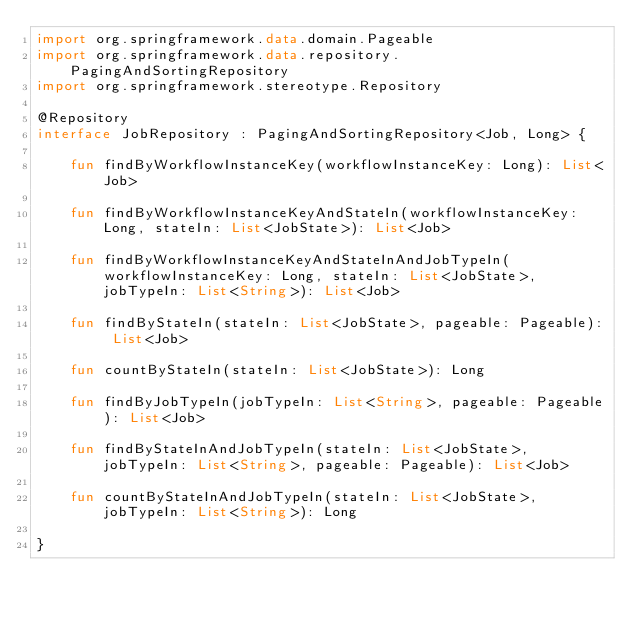Convert code to text. <code><loc_0><loc_0><loc_500><loc_500><_Kotlin_>import org.springframework.data.domain.Pageable
import org.springframework.data.repository.PagingAndSortingRepository
import org.springframework.stereotype.Repository

@Repository
interface JobRepository : PagingAndSortingRepository<Job, Long> {

    fun findByWorkflowInstanceKey(workflowInstanceKey: Long): List<Job>

    fun findByWorkflowInstanceKeyAndStateIn(workflowInstanceKey: Long, stateIn: List<JobState>): List<Job>

    fun findByWorkflowInstanceKeyAndStateInAndJobTypeIn(workflowInstanceKey: Long, stateIn: List<JobState>, jobTypeIn: List<String>): List<Job>

    fun findByStateIn(stateIn: List<JobState>, pageable: Pageable): List<Job>

    fun countByStateIn(stateIn: List<JobState>): Long

    fun findByJobTypeIn(jobTypeIn: List<String>, pageable: Pageable): List<Job>

    fun findByStateInAndJobTypeIn(stateIn: List<JobState>, jobTypeIn: List<String>, pageable: Pageable): List<Job>

    fun countByStateInAndJobTypeIn(stateIn: List<JobState>, jobTypeIn: List<String>): Long

}</code> 